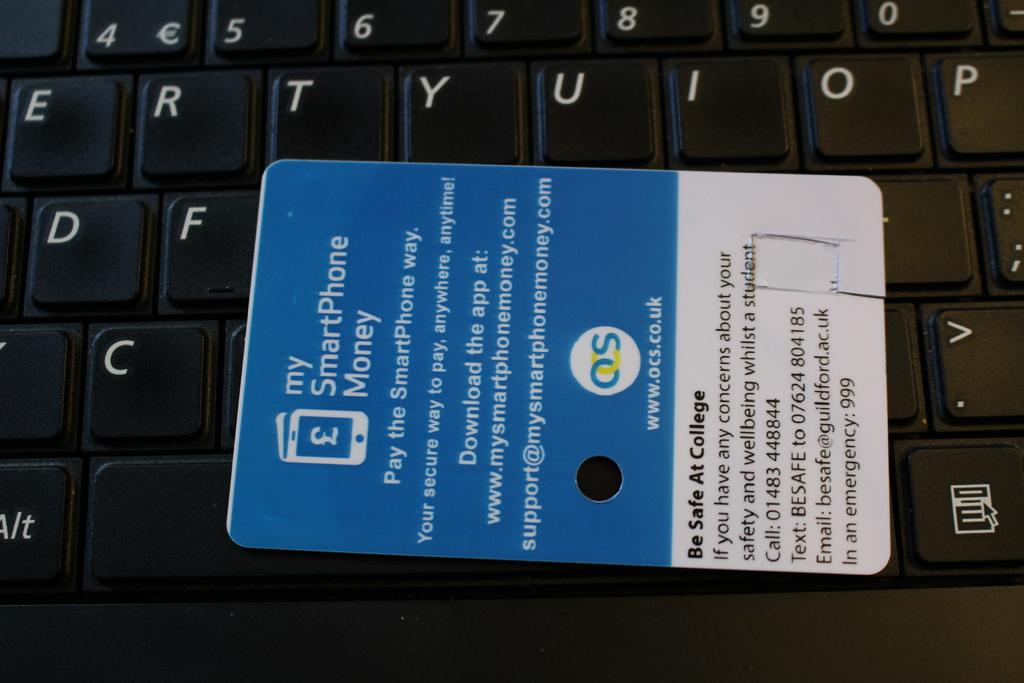<image>
Present a compact description of the photo's key features. A label on a keyboard that advertises "My Smartphone Money". 